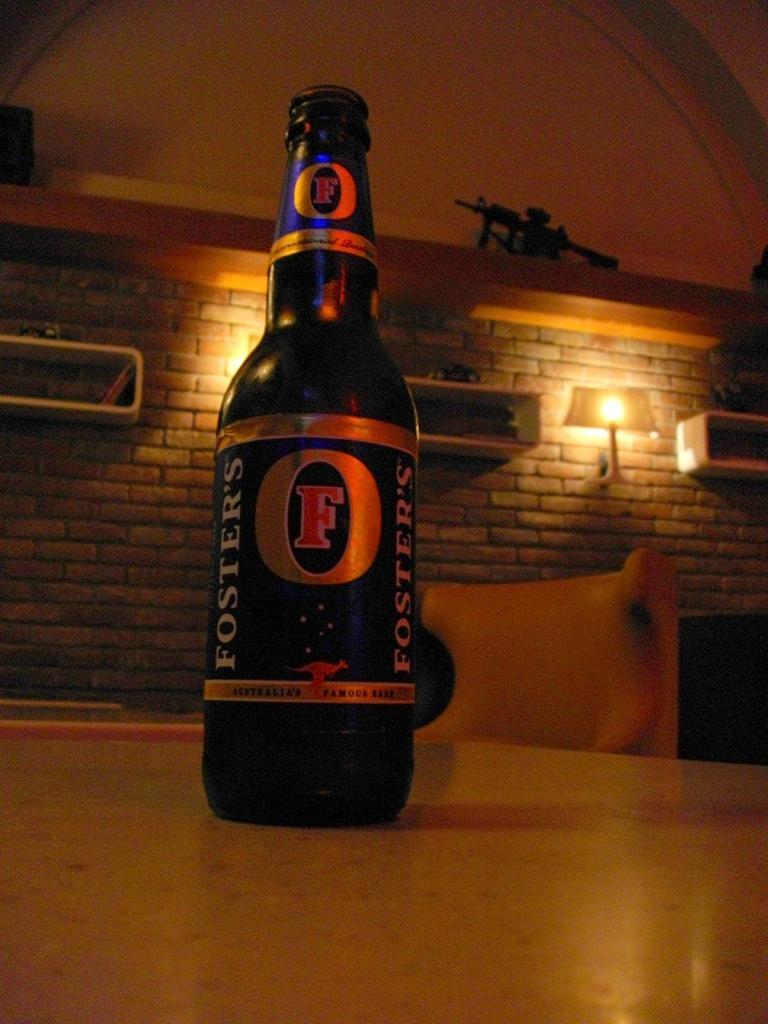Provide a one-sentence caption for the provided image. A bottle of Fosters lager sitting on a table. 